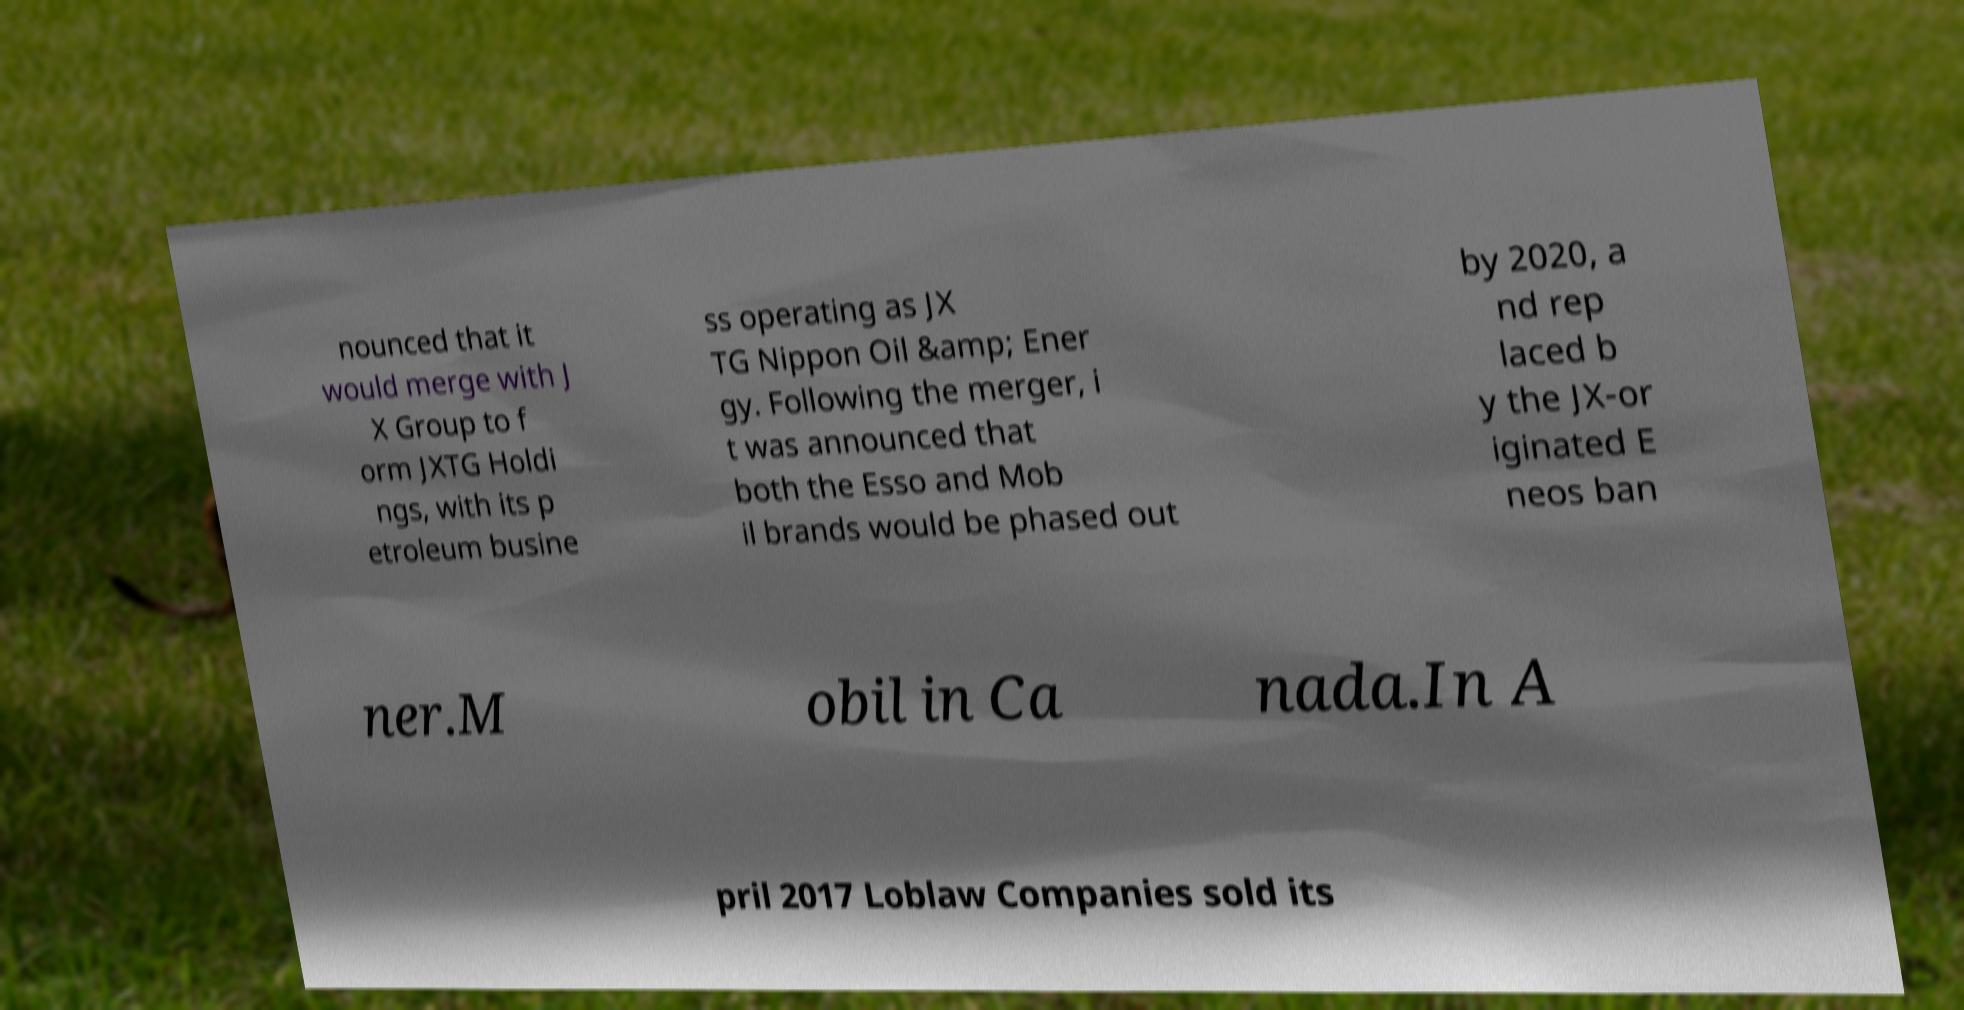Please identify and transcribe the text found in this image. nounced that it would merge with J X Group to f orm JXTG Holdi ngs, with its p etroleum busine ss operating as JX TG Nippon Oil &amp; Ener gy. Following the merger, i t was announced that both the Esso and Mob il brands would be phased out by 2020, a nd rep laced b y the JX-or iginated E neos ban ner.M obil in Ca nada.In A pril 2017 Loblaw Companies sold its 